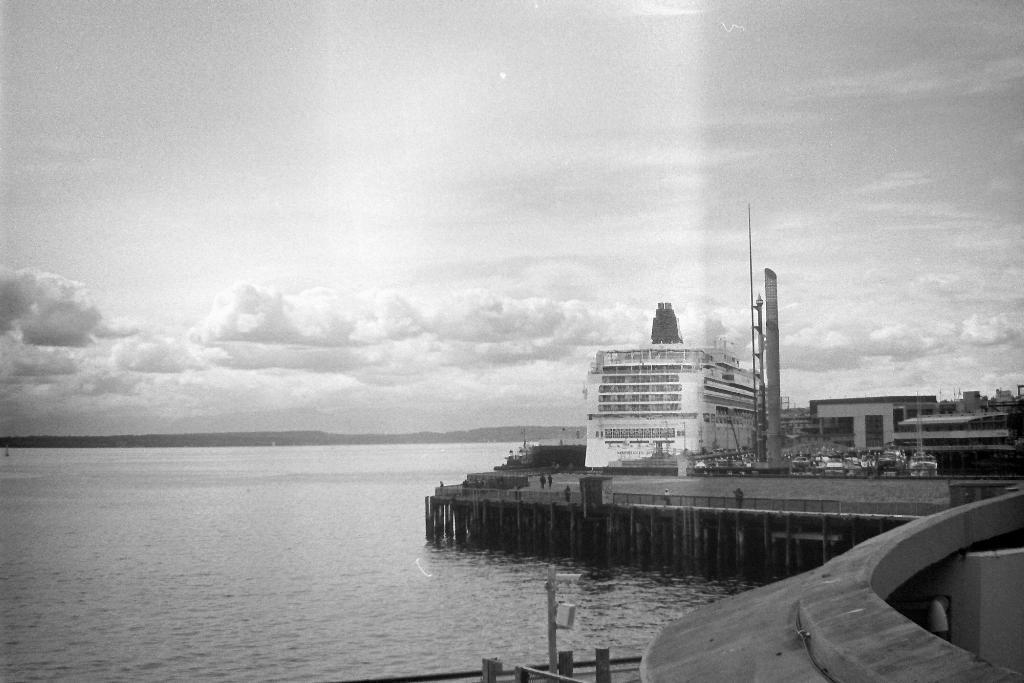Describe this image in one or two sentences. In this image I can see few buildings,vehicles,bridge,poles and water. The image is in black and white. 